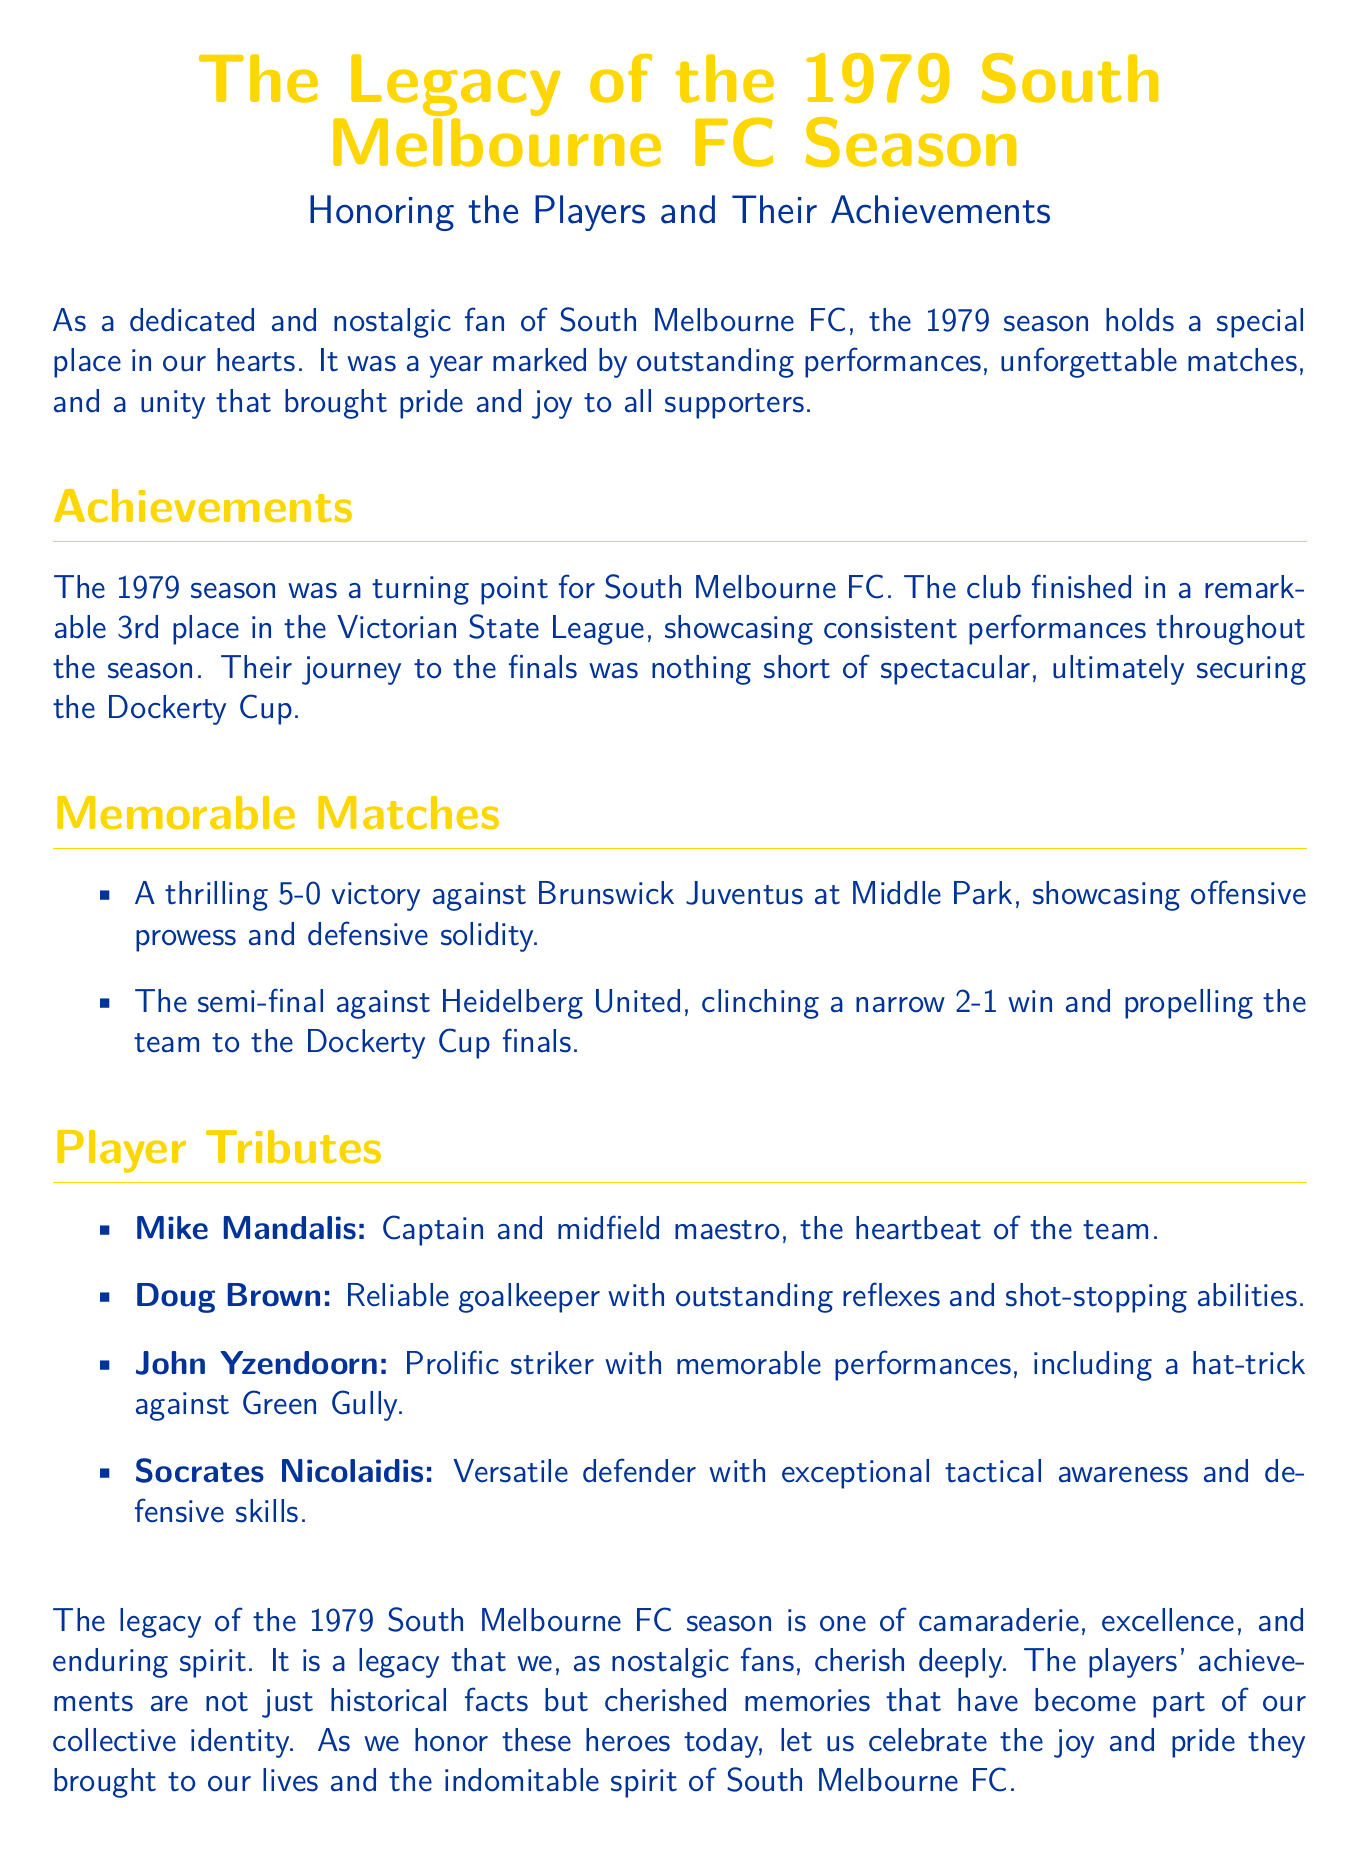what was the final league position of South Melbourne FC in 1979? The document states that South Melbourne FC finished in a remarkable 3rd place in the Victorian State League.
Answer: 3rd place what achievement did South Melbourne FC secure in the 1979 season? The document mentions that the club secured the Dockerty Cup during the season.
Answer: Dockerty Cup who was the team captain in 1979? The document refers to Mike Mandalis as the captain and midfield maestro of the team.
Answer: Mike Mandalis which player scored a hat-trick against Green Gully? The document indicates that John Yzendoorn had memorable performances including a hat-trick against Green Gully.
Answer: John Yzendoorn how many goals did South Melbourne FC score in their match against Brunswick Juventus? The document describes a thrilling 5-0 victory against Brunswick Juventus.
Answer: 5 goals what was the score in the semi-final against Heidelberg United? The document reveals that South Melbourne FC clinched a narrow 2-1 win in the semi-final against Heidelberg United.
Answer: 2-1 what qualities made Doug Brown notable as a player? The document highlights Doug Brown's outstanding reflexes and shot-stopping abilities as a reliable goalkeeper.
Answer: outstanding reflexes which color is used for the title in the document? The document specifies that the title color is southmelbournegold.
Answer: southmelbournegold what type of document is this? The document is structured as a eulogy honoring South Melbourne FC and its players.
Answer: eulogy 